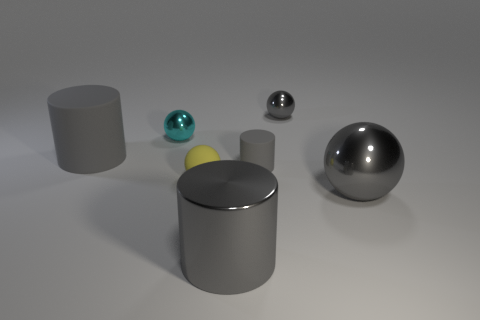Subtract all gray cylinders. How many were subtracted if there are1gray cylinders left? 2 Subtract all large gray metal balls. How many balls are left? 3 Subtract all gray balls. How many balls are left? 2 Add 1 tiny metal spheres. How many objects exist? 8 Subtract all cylinders. How many objects are left? 4 Add 5 small balls. How many small balls exist? 8 Subtract 1 gray balls. How many objects are left? 6 Subtract 1 cylinders. How many cylinders are left? 2 Subtract all red cylinders. Subtract all blue blocks. How many cylinders are left? 3 Subtract all red balls. How many purple cylinders are left? 0 